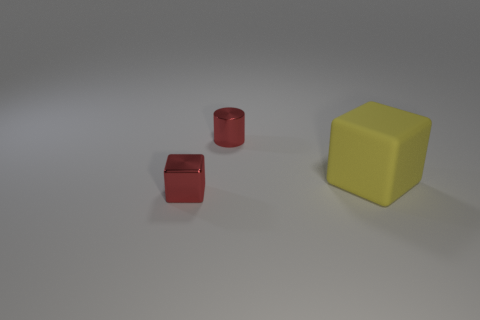There is a metallic object that is to the left of the red metallic cylinder; is its size the same as the small metal cylinder?
Your answer should be compact. Yes. What size is the red metallic cube?
Offer a terse response. Small. Are there any rubber things of the same color as the shiny cube?
Your answer should be very brief. No. How many small objects are either yellow blocks or cyan shiny spheres?
Provide a succinct answer. 0. There is a thing that is to the right of the tiny red block and to the left of the large yellow thing; what is its size?
Offer a very short reply. Small. There is a yellow cube; how many large yellow objects are to the right of it?
Make the answer very short. 0. The object that is left of the big matte object and in front of the tiny cylinder has what shape?
Give a very brief answer. Cube. There is a tiny thing that is the same color as the shiny cylinder; what is it made of?
Offer a terse response. Metal. How many cylinders are either big matte objects or gray rubber things?
Provide a succinct answer. 0. There is a metal thing that is the same color as the small shiny cube; what is its size?
Offer a terse response. Small. 